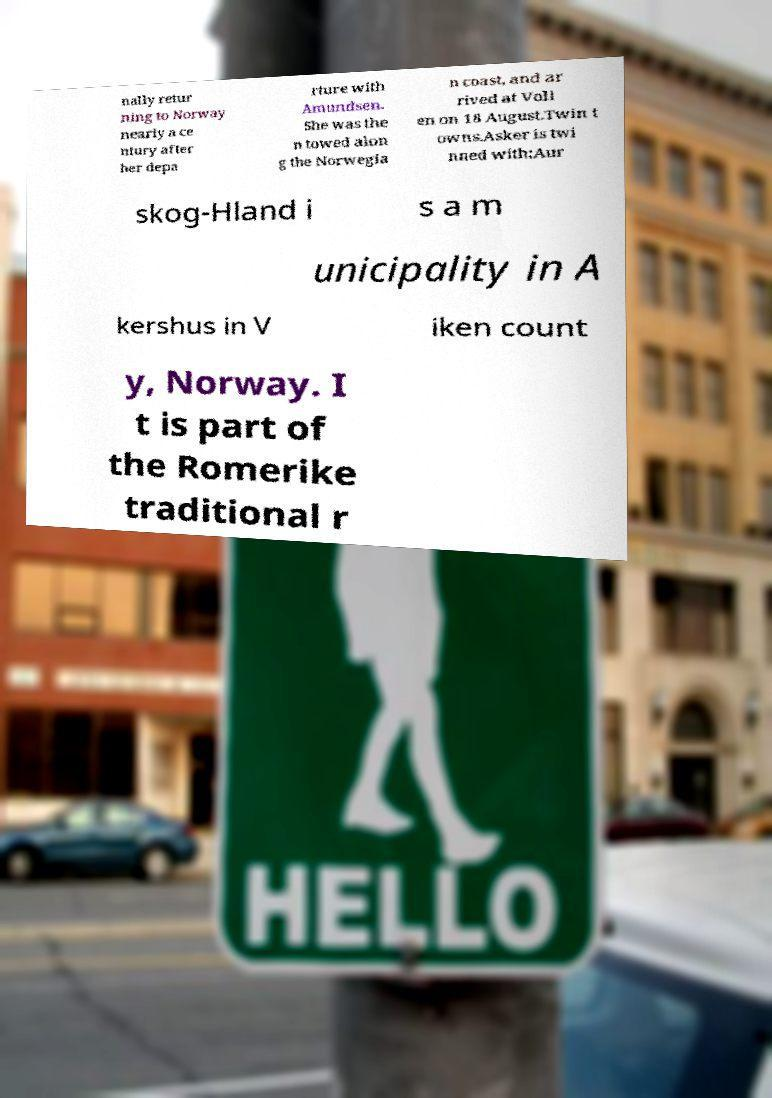Could you extract and type out the text from this image? nally retur ning to Norway nearly a ce ntury after her depa rture with Amundsen. She was the n towed alon g the Norwegia n coast, and ar rived at Voll en on 18 August.Twin t owns.Asker is twi nned with:Aur skog-Hland i s a m unicipality in A kershus in V iken count y, Norway. I t is part of the Romerike traditional r 